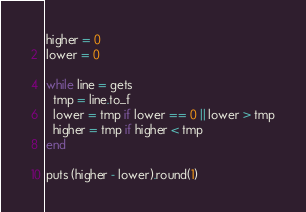Convert code to text. <code><loc_0><loc_0><loc_500><loc_500><_Ruby_>higher = 0
lower = 0

while line = gets
  tmp = line.to_f
  lower = tmp if lower == 0 || lower > tmp
  higher = tmp if higher < tmp
end

puts (higher - lower).round(1)</code> 